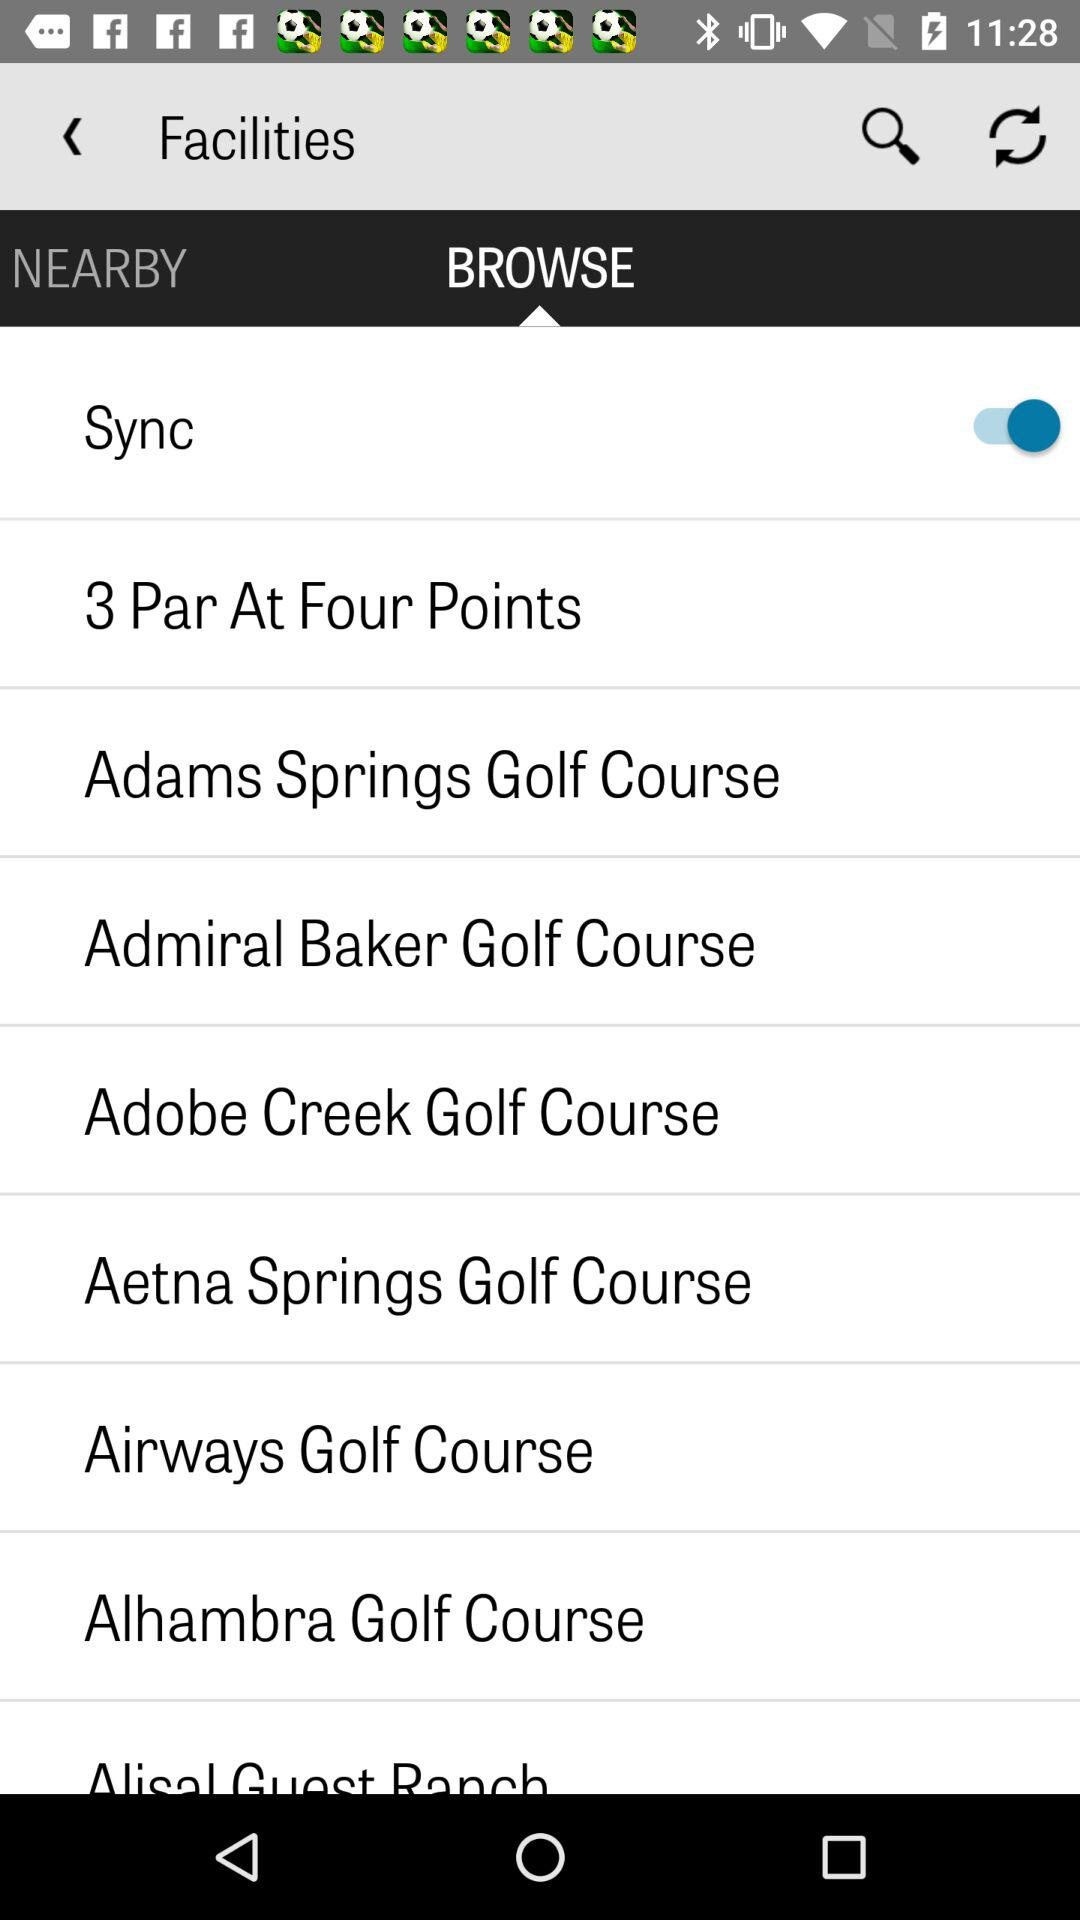How many facilities are available?
Answer the question using a single word or phrase. 8 